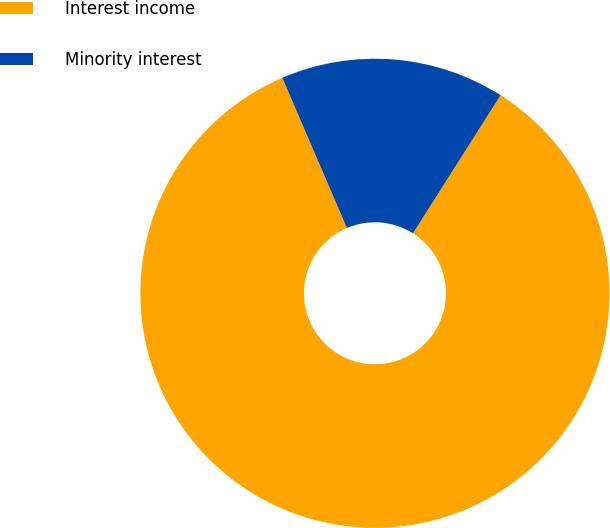Convert chart to OTSL. <chart><loc_0><loc_0><loc_500><loc_500><pie_chart><fcel>Interest income<fcel>Minority interest<nl><fcel>84.54%<fcel>15.46%<nl></chart> 